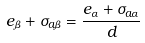<formula> <loc_0><loc_0><loc_500><loc_500>e _ { \beta } + \sigma _ { a \beta } = \frac { e _ { \alpha } + \sigma _ { a \alpha } } { d }</formula> 